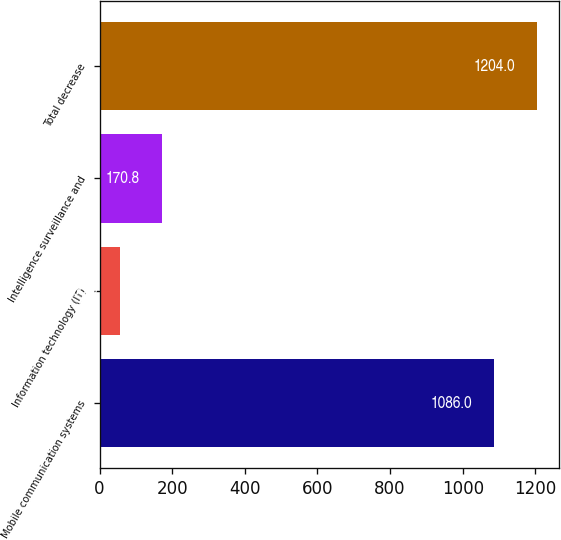Convert chart. <chart><loc_0><loc_0><loc_500><loc_500><bar_chart><fcel>Mobile communication systems<fcel>Information technology (IT)<fcel>Intelligence surveillance and<fcel>Total decrease<nl><fcel>1086<fcel>56<fcel>170.8<fcel>1204<nl></chart> 